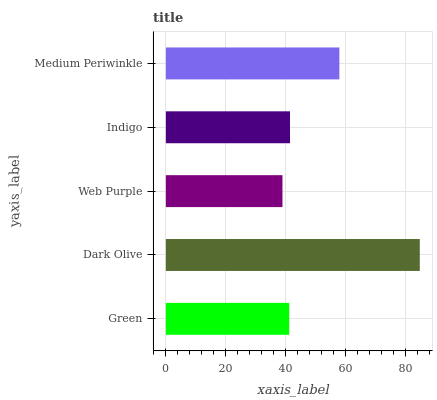Is Web Purple the minimum?
Answer yes or no. Yes. Is Dark Olive the maximum?
Answer yes or no. Yes. Is Dark Olive the minimum?
Answer yes or no. No. Is Web Purple the maximum?
Answer yes or no. No. Is Dark Olive greater than Web Purple?
Answer yes or no. Yes. Is Web Purple less than Dark Olive?
Answer yes or no. Yes. Is Web Purple greater than Dark Olive?
Answer yes or no. No. Is Dark Olive less than Web Purple?
Answer yes or no. No. Is Indigo the high median?
Answer yes or no. Yes. Is Indigo the low median?
Answer yes or no. Yes. Is Medium Periwinkle the high median?
Answer yes or no. No. Is Green the low median?
Answer yes or no. No. 